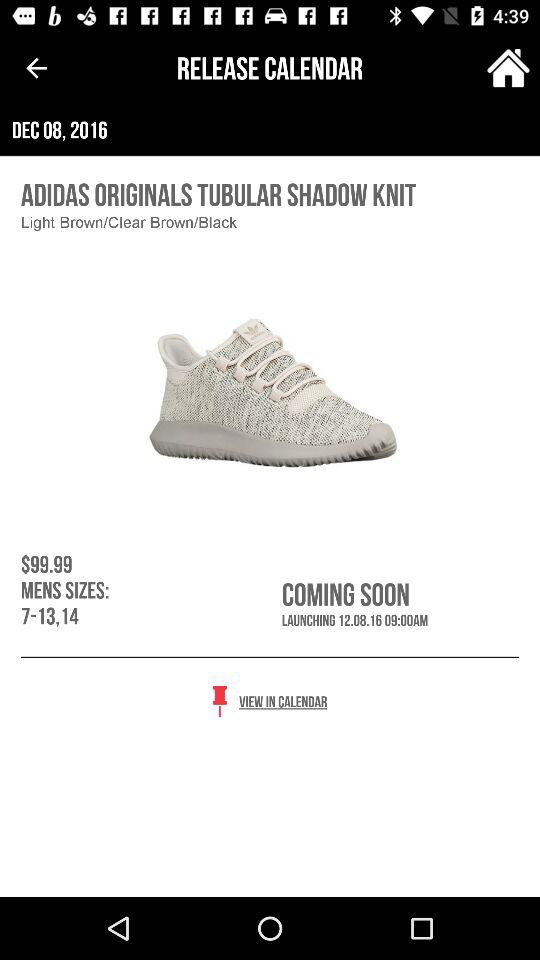On what date is the shoe launching? The date is 12.08.16. 